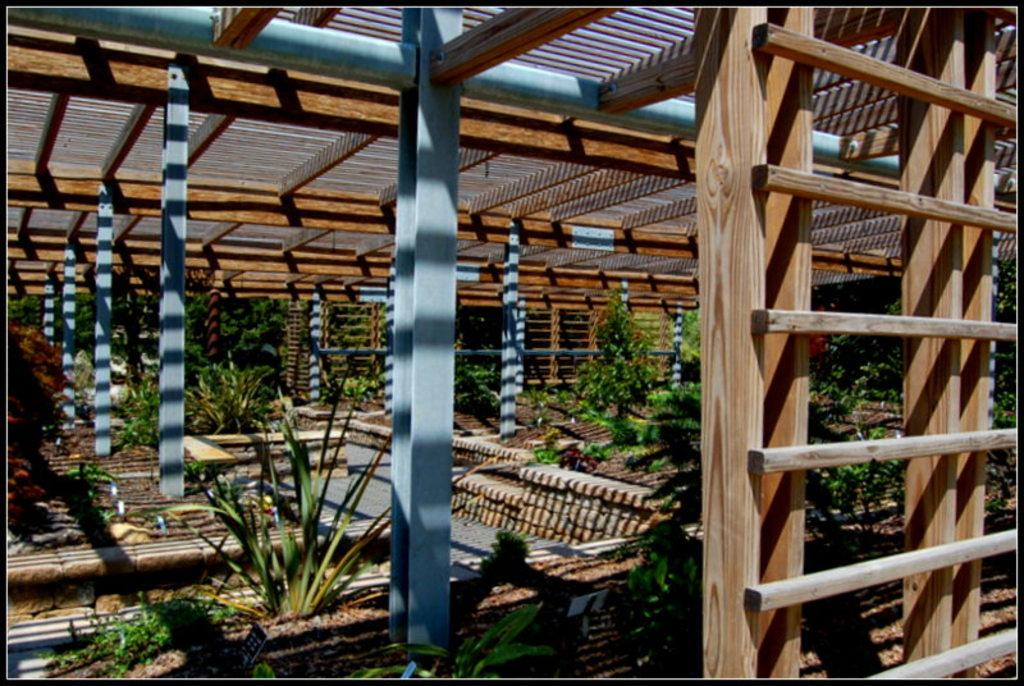What type of structures are in the image? There are wooden shelters in the image. What color are the pillars of the wooden shelters? The wooden shelters have blue color pillars. What can be found under the wooden shelters? Plants are present under the shelters. Can you see any eyes on the wooden shelters in the image? There are no eyes present on the wooden shelters in the image. Are there any snails crawling on the plants under the shelters? The presence of snails is not mentioned in the image, so we cannot determine if they are present or not. 